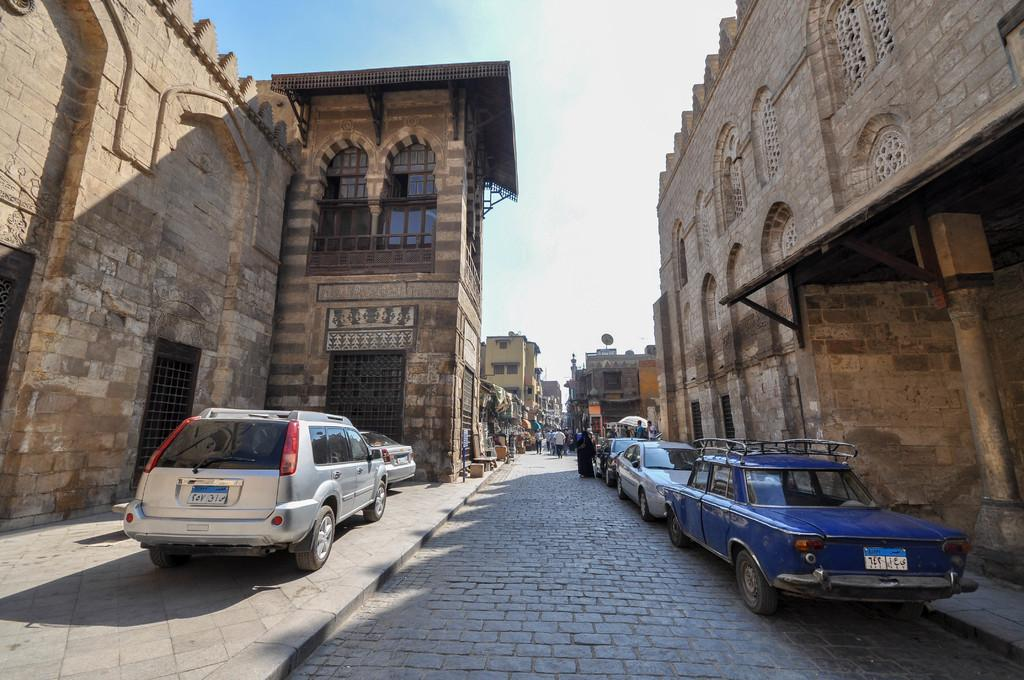What type of structures can be seen in the image? There are buildings in the image. What else is present in the image besides buildings? There are vehicles and people on the road in the image. How many trees can be seen in the image? There are no trees visible in the image; it features buildings, vehicles, and people on the road. What type of ship is present in the image? There is no ship present in the image. 